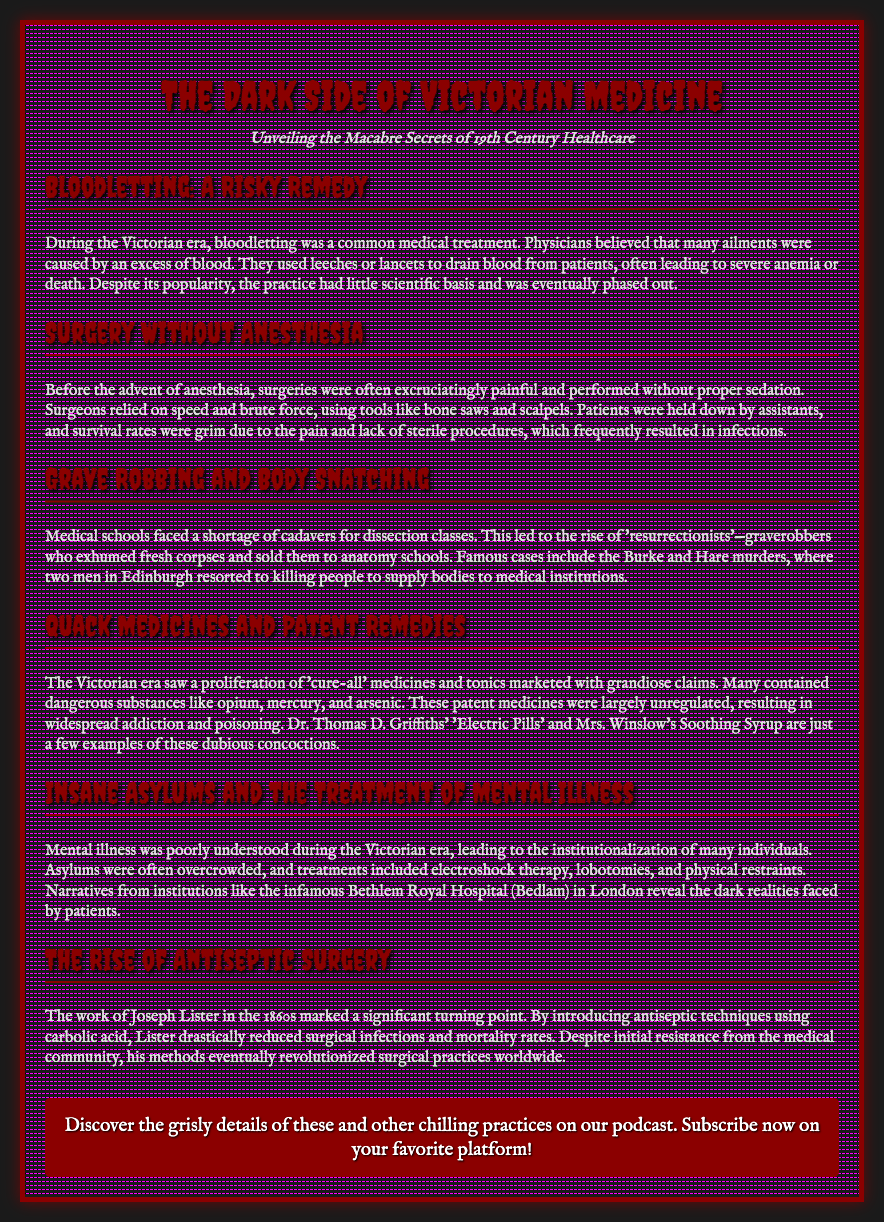what was a common medical treatment during the Victorian era? Bloodletting was a common medical treatment believed to treat many ailments attributed to an excess of blood.
Answer: Bloodletting who was a key figure in introducing antiseptic techniques? Joseph Lister introduced antiseptic techniques using carbolic acid in the 1860s.
Answer: Joseph Lister what dangerous substances were commonly found in patent remedies? Many patent remedies contained dangerous substances like opium, mercury, and arsenic.
Answer: Opium, mercury, arsenic what was the nickname for the infamous Bethlem Royal Hospital? The Bethlem Royal Hospital was infamously known as Bedlam, revealing dark realities faced by patients.
Answer: Bedlam which gruesome practice involved exhuming bodies? The practice of grave robbing involved exhuming bodies for use in medical education.
Answer: Grave robbing how did surgery practices change with the advent of anesthesia? Prior to anesthesia, surgeries were extremely painful and lacking in sterile procedures, leading to high risks.
Answer: Painful and risky what were the consequences of bloodletting on patients? Bloodletting often led to severe anemia or death due to excessive blood loss.
Answer: Severe anemia or death what type of healthcare institutions were often overcrowded during the Victorian era? Insane asylums were often overcrowded due to the institutionalization of many individuals with mental illnesses.
Answer: Insane asylums 